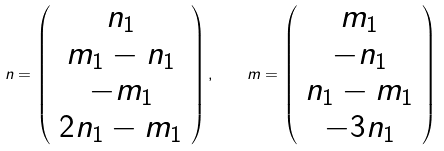Convert formula to latex. <formula><loc_0><loc_0><loc_500><loc_500>n = \left ( \begin{array} { c } n _ { 1 } \\ m _ { 1 } - n _ { 1 } \\ - m _ { 1 } \\ 2 n _ { 1 } - m _ { 1 } \end{array} \right ) , \quad m = \left ( \begin{array} { c } m _ { 1 } \\ - n _ { 1 } \\ n _ { 1 } - m _ { 1 } \\ - 3 n _ { 1 } \end{array} \right )</formula> 